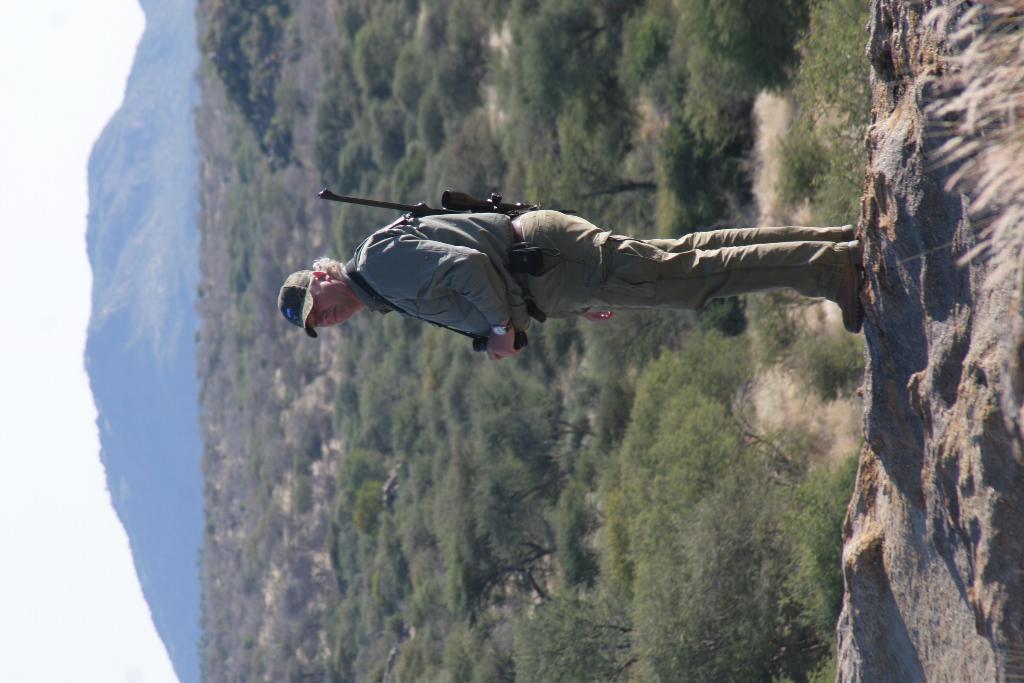Could you give a brief overview of what you see in this image? In this image we can see a person holding the object and carrying a gun, there are few trees, mountains and the sky. 